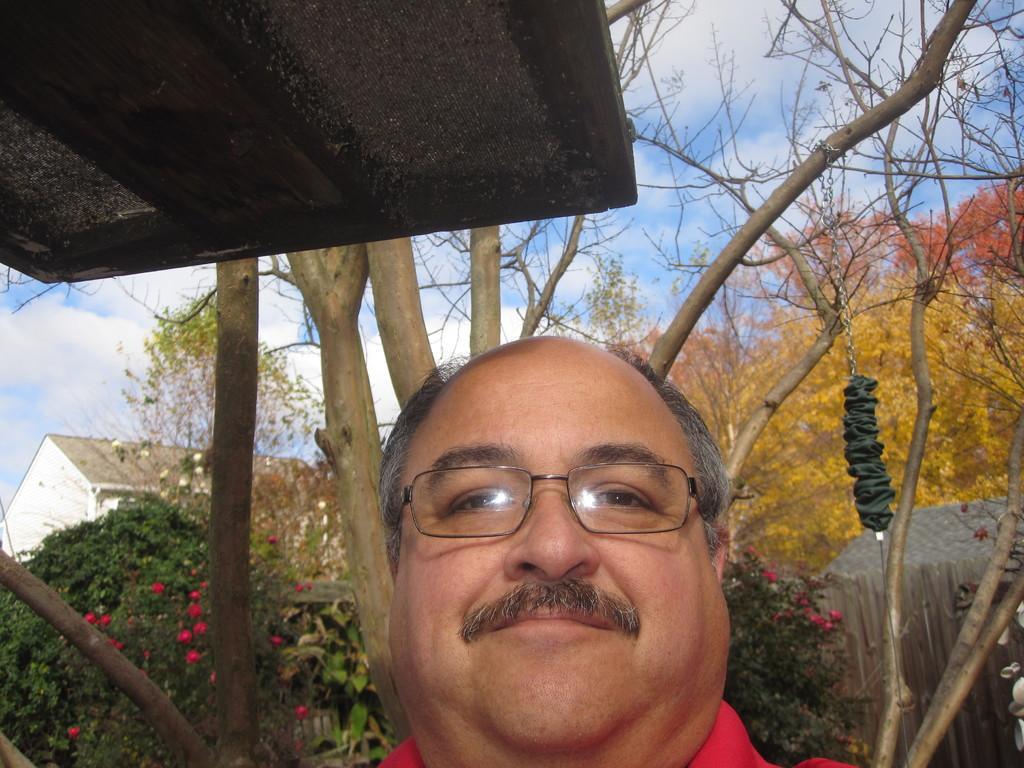Could you give a brief overview of what you see in this image? In this image I see a man who is wearing spectacle and I see a black color thing over here. In the background I see the trees and I see flowers which are of red in color and I see the clear sky and I see a building over here and I see few more flowers which are of white in color and I see a chain over here and I see black color thing connected to it. 